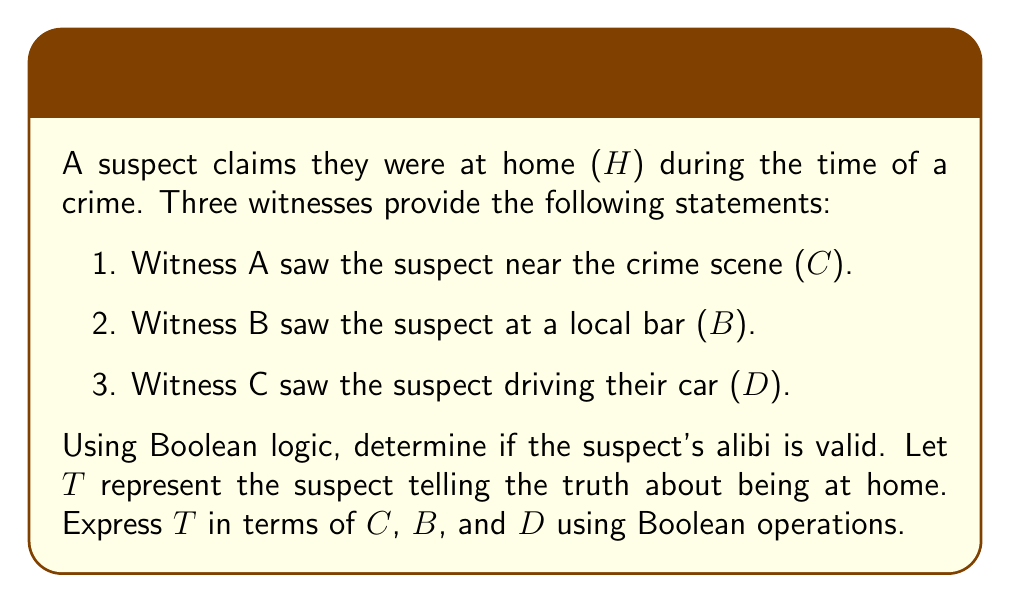Solve this math problem. Let's approach this step-by-step:

1) First, we need to understand what each witness statement means in terms of the suspect's alibi:
   - If C is true, the suspect was at the crime scene, so they're not at home.
   - If B is true, the suspect was at the bar, so they're not at home.
   - If D is true, the suspect was driving, so they're not at home.

2) For the suspect's alibi to be valid (T to be true), all of these statements must be false. In Boolean logic, this is equivalent to the NOR operation.

3) The NOR operation is true only when all inputs are false. It can be expressed using AND and NOT operations:

   $T = \overline{C} \cdot \overline{B} \cdot \overline{D}$

4) This can also be written using De Morgan's law:

   $T = \overline{C + B + D}$

5) In words, this means "The suspect is telling the truth if and only if they were not at the crime scene AND not at the bar AND not driving."

6) If any of C, B, or D is true, T will be false, invalidating the suspect's alibi.
Answer: $T = \overline{C} \cdot \overline{B} \cdot \overline{D}$ or $T = \overline{C + B + D}$ 